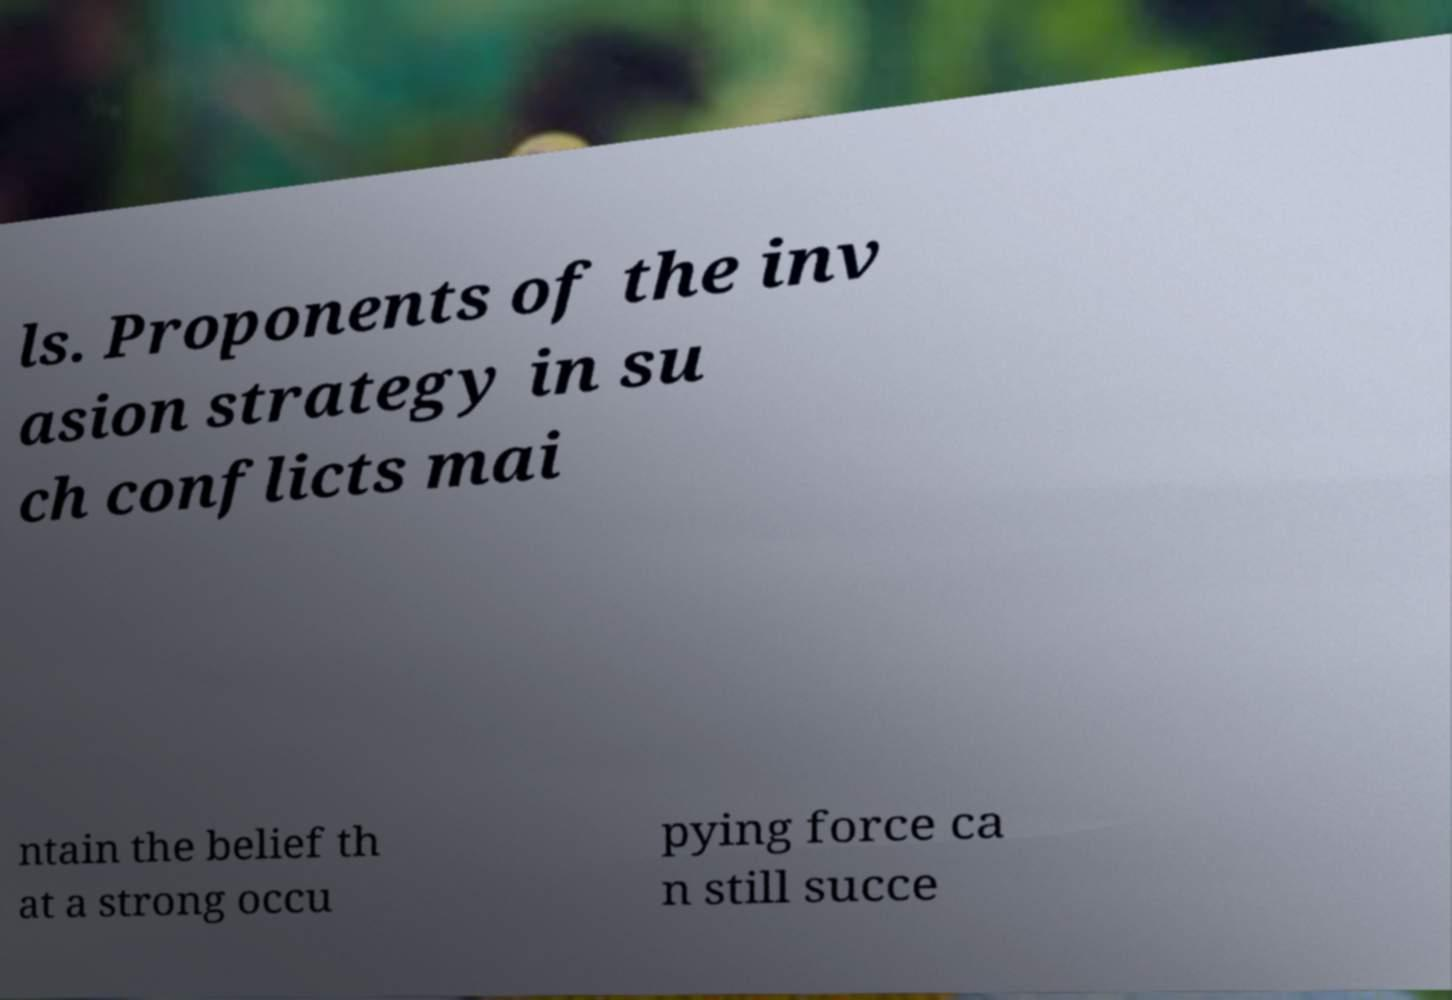For documentation purposes, I need the text within this image transcribed. Could you provide that? ls. Proponents of the inv asion strategy in su ch conflicts mai ntain the belief th at a strong occu pying force ca n still succe 